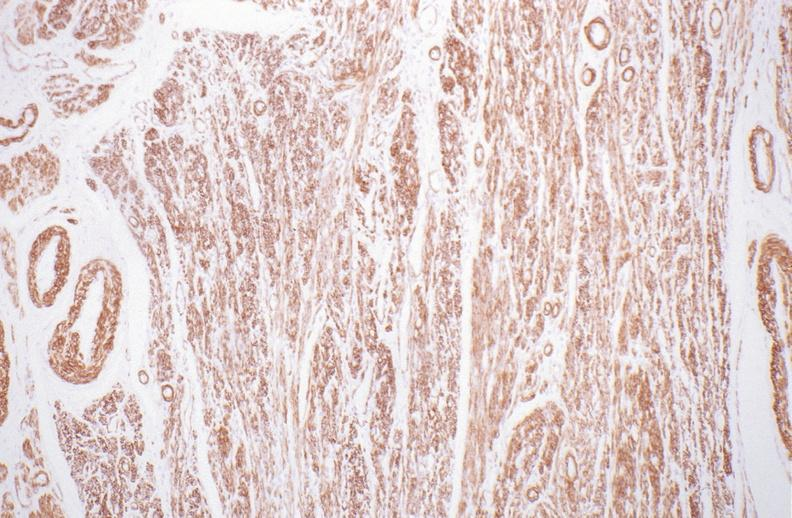what stain?
Answer the question using a single word or phrase. Normal uterus, alpha smooth muscle actin immunohistochemical 